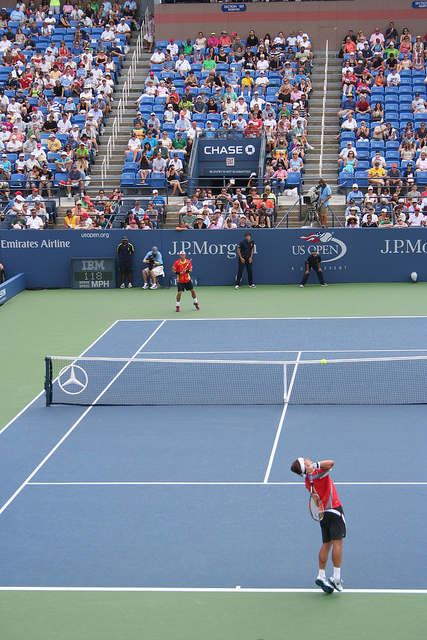Identify the text contained in this image. IBM 118 MPH Airline Emirates CHASE J.P.M OPEN US J.P.Morgan 